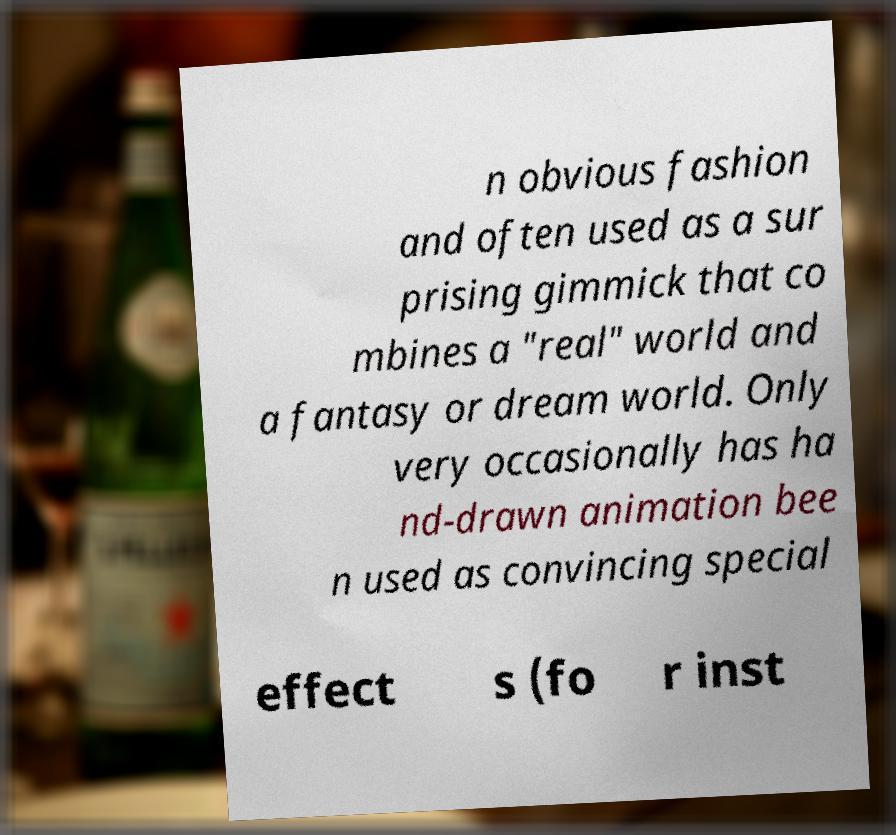Can you accurately transcribe the text from the provided image for me? n obvious fashion and often used as a sur prising gimmick that co mbines a "real" world and a fantasy or dream world. Only very occasionally has ha nd-drawn animation bee n used as convincing special effect s (fo r inst 